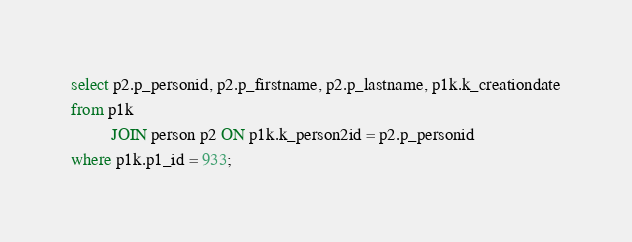<code> <loc_0><loc_0><loc_500><loc_500><_SQL_>select p2.p_personid, p2.p_firstname, p2.p_lastname, p1k.k_creationdate
from p1k
         JOIN person p2 ON p1k.k_person2id = p2.p_personid
where p1k.p1_id = 933;
</code> 